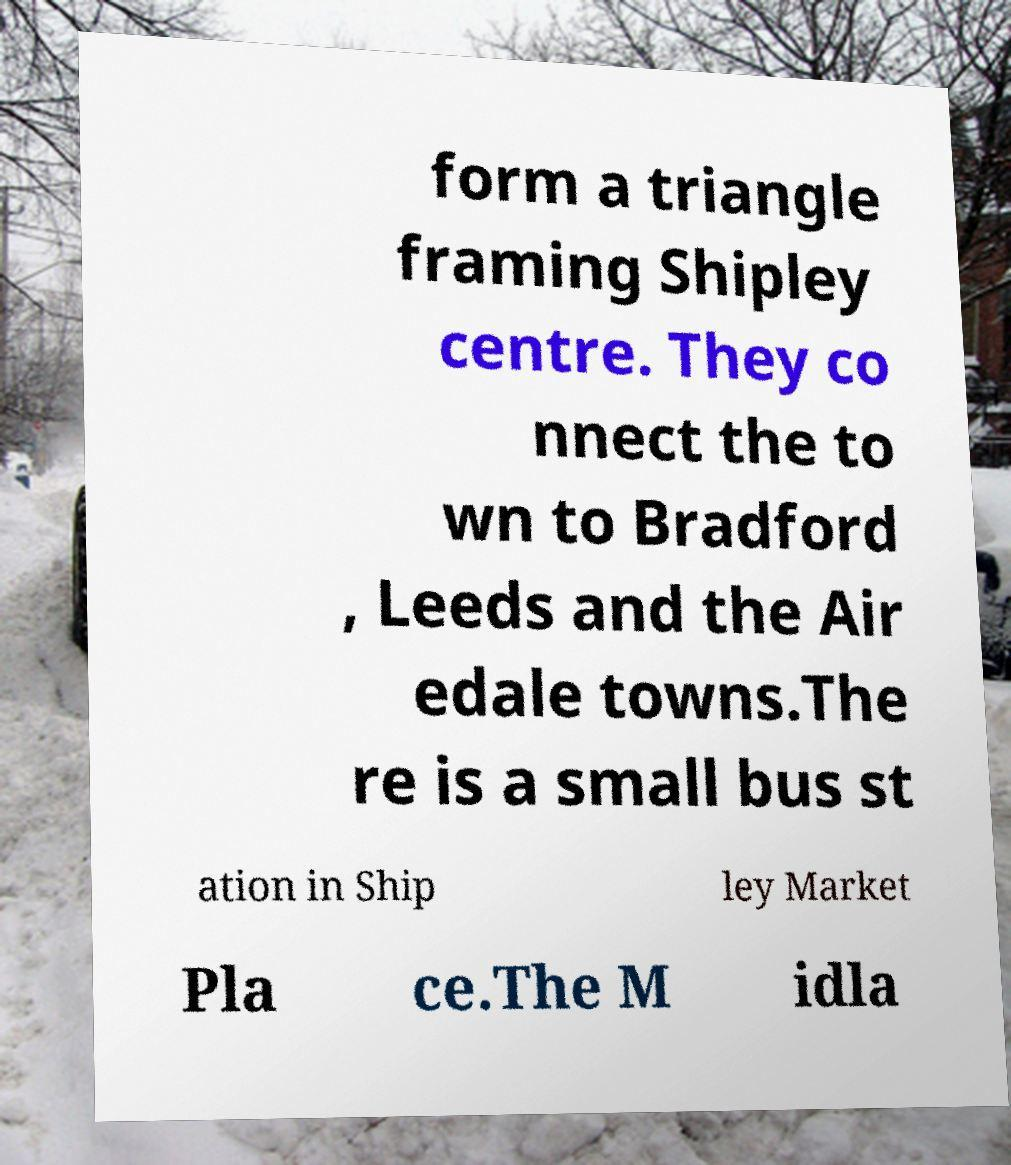Can you read and provide the text displayed in the image?This photo seems to have some interesting text. Can you extract and type it out for me? form a triangle framing Shipley centre. They co nnect the to wn to Bradford , Leeds and the Air edale towns.The re is a small bus st ation in Ship ley Market Pla ce.The M idla 